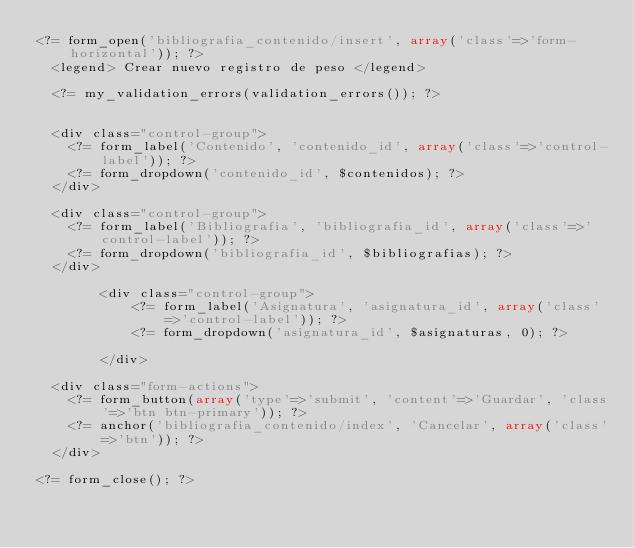<code> <loc_0><loc_0><loc_500><loc_500><_PHP_><?= form_open('bibliografia_contenido/insert', array('class'=>'form-horizontal')); ?>
	<legend> Crear nuevo registro de peso </legend>

	<?= my_validation_errors(validation_errors()); ?>


	<div class="control-group">
		<?= form_label('Contenido', 'contenido_id', array('class'=>'control-label')); ?>
		<?= form_dropdown('contenido_id', $contenidos); ?>
	</div>

	<div class="control-group">
		<?= form_label('Bibliografia', 'bibliografia_id', array('class'=>'control-label')); ?>
		<?= form_dropdown('bibliografia_id', $bibliografias); ?>
	</div>
        
        <div class="control-group">
            <?= form_label('Asignatura', 'asignatura_id', array('class'=>'control-label')); ?>
            <?= form_dropdown('asignatura_id', $asignaturas, 0); ?>
            
        </div>

	<div class="form-actions">
		<?= form_button(array('type'=>'submit', 'content'=>'Guardar', 'class'=>'btn btn-primary')); ?>
		<?= anchor('bibliografia_contenido/index', 'Cancelar', array('class'=>'btn')); ?>
	</div>

<?= form_close(); ?>
</code> 